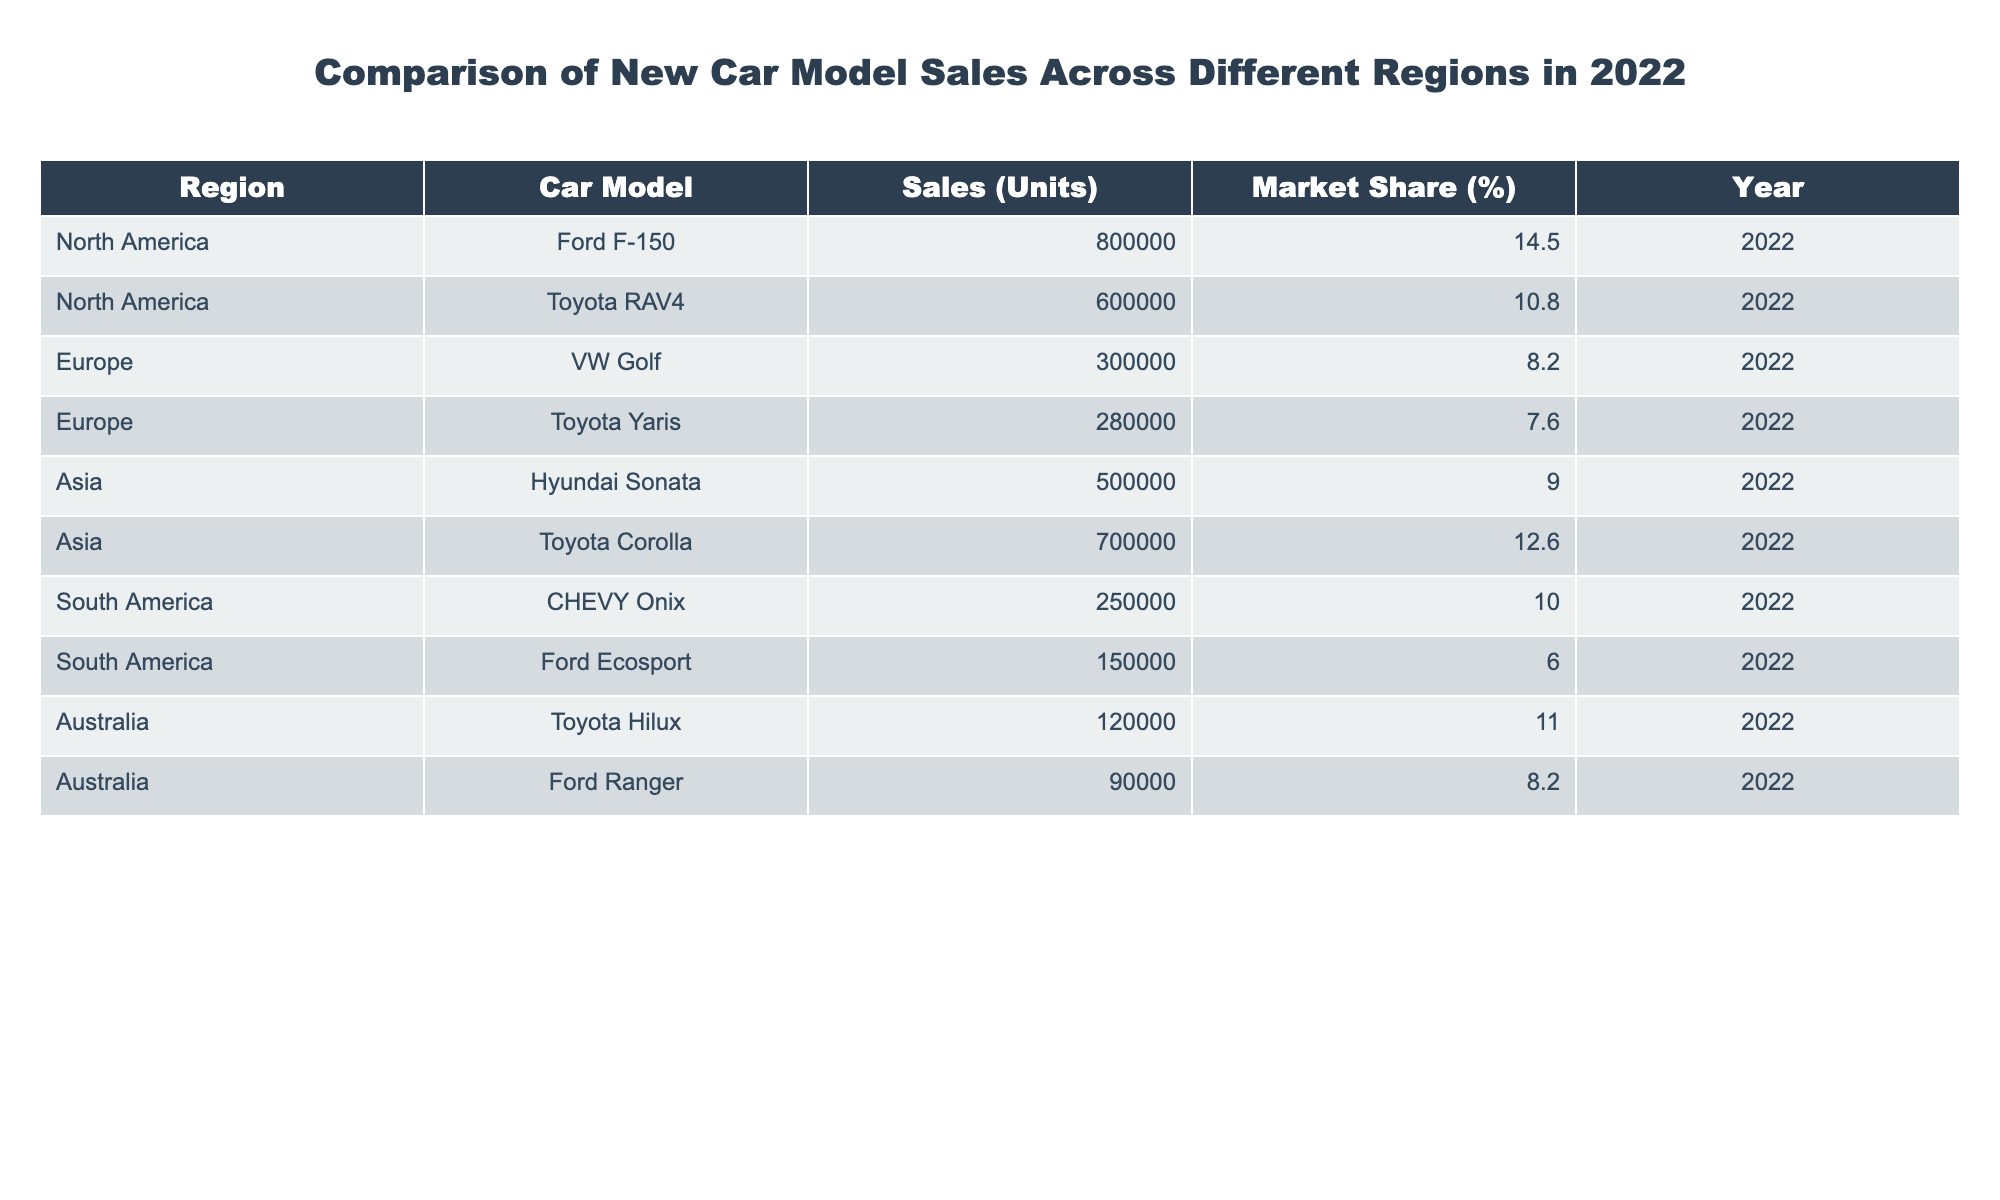What is the total number of units sold for the Ford F-150 in North America in 2022? The table shows that the Ford F-150 sold 800,000 units in North America in 2022. Therefore, the total number of units sold for this model is directly stated in the table.
Answer: 800000 Which car model has the highest market share in North America? According to the table, the Ford F-150 has a market share of 14.5%, which is higher than any other model listed for North America. Thus, it has the highest market share in that region.
Answer: Ford F-150 What is the average number of units sold in Europe for the car models listed? The two car models in Europe are VW Golf (300,000 units) and Toyota Yaris (280,000 units). To calculate the average, we sum them up: 300,000 + 280,000 = 580,000, and then divide by 2 (the number of models), which gives us 580,000 / 2 = 290,000.
Answer: 290000 Is the market share of the Toyota Corolla higher than that of the Ford Ecosport in South America? The table indicates that the Toyota Corolla has a market share of 12.6%, while the Ford Ecosport has a market share of 6.0%. Since 12.6% is greater than 6.0%, the assertion that the Toyota Corolla has a higher market share is true.
Answer: Yes How many more units did the Toyota RAV4 sell compared to the CHEVY Onix in 2022? The Toyota RAV4 sold 600,000 units while the CHEVY Onix sold 250,000 units. To find the difference, we subtract the units sold for CHEVY Onix from those sold for Toyota RAV4: 600,000 - 250,000 = 350,000. Thus, the Toyota RAV4 sold 350,000 more units than the CHEVY Onix.
Answer: 350000 What percentage of the total sales do the car models sold in Asia represent? The total sales for Asia include the Hyundai Sonata (500,000 units) and Toyota Corolla (700,000 units), which is 1,200,000 units combined. The total units sold across all models in the table is 3,500,000 (derived by summing all units). The percentage is then calculated as (1,200,000 / 3,500,000) * 100 = 34.29%. Therefore, the total sales for car models sold in Asia represent approximately 34.29% of all sales.
Answer: 34.29% Which region sold the least number of units for a single car model? Looking at the sales data, the Ford Ranger in Australia sold the least at 90,000 units compared to the other car models listed. By scanning through the table, it's clear that no model outside of Australia had lower sales than this figure.
Answer: Ford Ranger Is the total market share of the Toyota models in North America greater than 20%? The Toyota RAV4 has a market share of 10.8%, and the car model from Asia, the Toyota Corolla, is not included in the North America section of the table. Therefore, adding the market shares would only return the RAV4's market share. As it stands at 10.8%, this is indeed less than 20%, thus the assertion is false.
Answer: No How does the market share of car models in Australia compare to those in South America? In Australia, the Toyota Hilux has an 11.0% market share, and the Ford Ranger has 8.2%; thus, the total is 19.2%. In South America, the CHEVY Onix has 10.0% and the Ford Ecosport has 6.0%, totaling 16.0%. Comparing the two totals, 19.2% (Australia) is greater than 16.0% (South America), indicating that car models in Australia have a higher market share overall.
Answer: Australia has a higher market share 